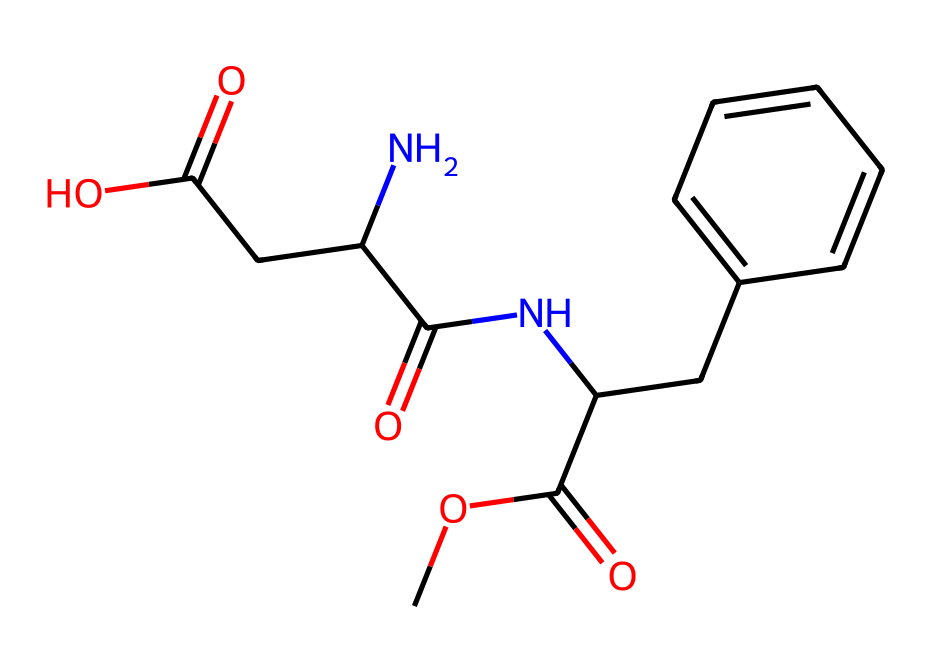What is the molecular formula of aspartame? To determine the molecular formula, we analyze the SMILES representation and count each type of atom present. The atoms represented include carbon (C), hydrogen (H), nitrogen (N), and oxygen (O). Counting gives 14 carbon, 18 hydrogen, 2 nitrogen, and 3 oxygen atoms. Therefore, the molecular formula is C14H18N2O3.
Answer: C14H18N2O3 How many rings are present in the structure of aspartame? By examining the SMILES representation, we look for cyclic features in the structure. The notation of the structure shows a phenyl ring (the part containing CC1=CC=CC=C1), which denotes a single ring in the chemical structure of aspartame. Thus, there is one ring present.
Answer: 1 What type of functional groups can be identified in aspartame? Analyzing the SMILES representation reveals various functional groups through common patterns, such as esters (COC(=O)), amides (C(N)NC(=O)), and carboxylic acids (CC(=O)O). Identifying these leads to the conclusion that aspartame contains these significant functional groups.
Answer: ester, amide, carboxylic acid What is the primary use of aspartame in food products? Aspartame is commonly used as an artificial sweetener in various low-calorie and sugar-free products, which is a key application due to its sweetening properties without adding significant calories.
Answer: sweetener Which atoms in aspartame are responsible for its sweet taste? Aspartame's sweetness is attributed to the presence of specific functional groups, chiefly the amide and ester linkages, as these structures interact with taste receptors on the tongue. Thus, the nitrogen (N) and carbon (C) from the amide groups are particularly responsible.
Answer: nitrogen, carbon What is the ratio of carbon to nitrogen atoms in aspartame? To find the ratio of carbon to nitrogen, we need to count the respective atoms in the molecular formula: there are 14 carbon (C) atoms and 2 nitrogen (N) atoms. Therefore, the ratio is calculated as 14:2, which simplifies to 7:1.
Answer: 7:1 